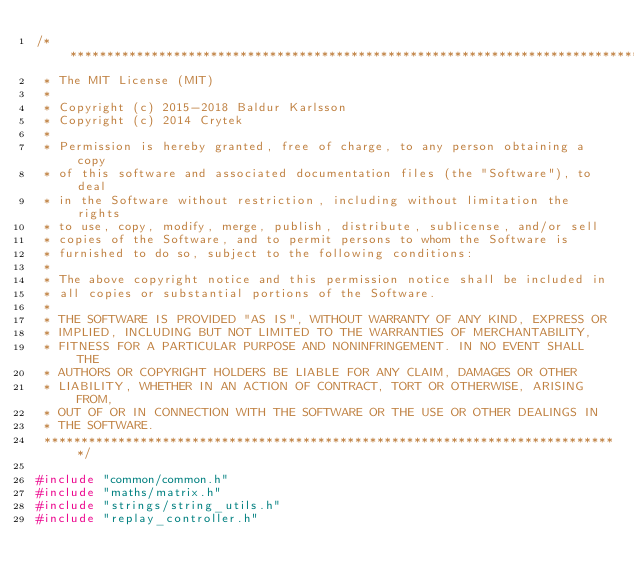Convert code to text. <code><loc_0><loc_0><loc_500><loc_500><_C++_>/******************************************************************************
 * The MIT License (MIT)
 *
 * Copyright (c) 2015-2018 Baldur Karlsson
 * Copyright (c) 2014 Crytek
 *
 * Permission is hereby granted, free of charge, to any person obtaining a copy
 * of this software and associated documentation files (the "Software"), to deal
 * in the Software without restriction, including without limitation the rights
 * to use, copy, modify, merge, publish, distribute, sublicense, and/or sell
 * copies of the Software, and to permit persons to whom the Software is
 * furnished to do so, subject to the following conditions:
 *
 * The above copyright notice and this permission notice shall be included in
 * all copies or substantial portions of the Software.
 *
 * THE SOFTWARE IS PROVIDED "AS IS", WITHOUT WARRANTY OF ANY KIND, EXPRESS OR
 * IMPLIED, INCLUDING BUT NOT LIMITED TO THE WARRANTIES OF MERCHANTABILITY,
 * FITNESS FOR A PARTICULAR PURPOSE AND NONINFRINGEMENT. IN NO EVENT SHALL THE
 * AUTHORS OR COPYRIGHT HOLDERS BE LIABLE FOR ANY CLAIM, DAMAGES OR OTHER
 * LIABILITY, WHETHER IN AN ACTION OF CONTRACT, TORT OR OTHERWISE, ARISING FROM,
 * OUT OF OR IN CONNECTION WITH THE SOFTWARE OR THE USE OR OTHER DEALINGS IN
 * THE SOFTWARE.
 ******************************************************************************/

#include "common/common.h"
#include "maths/matrix.h"
#include "strings/string_utils.h"
#include "replay_controller.h"
</code> 